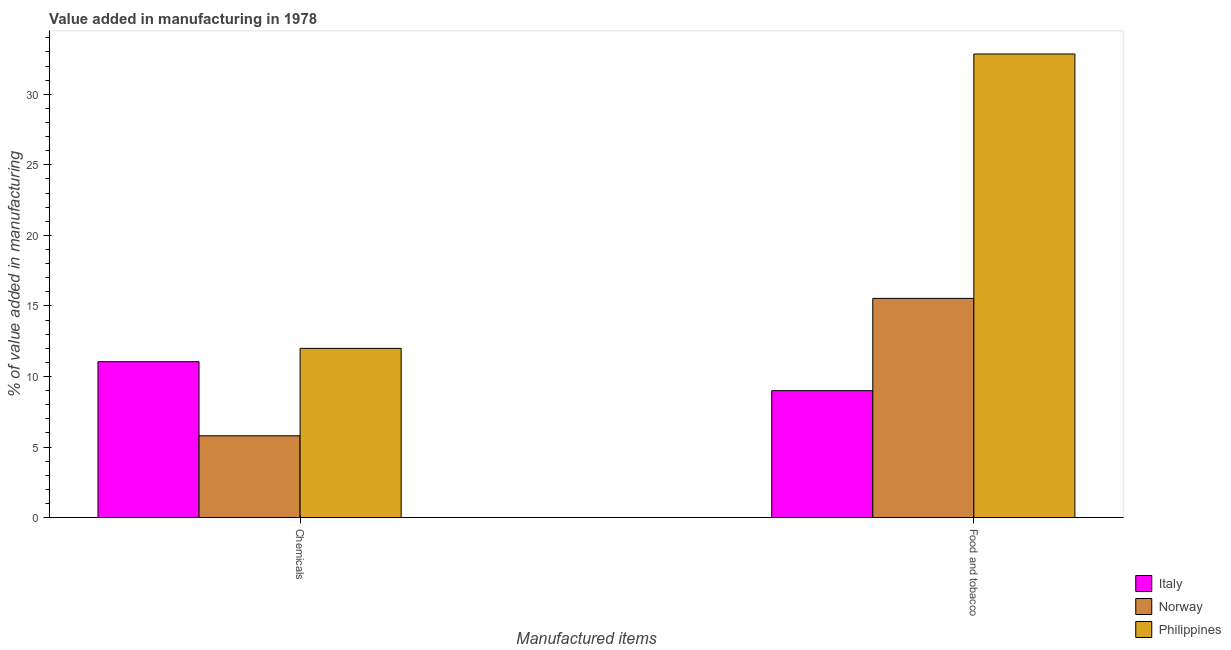How many groups of bars are there?
Offer a terse response. 2. How many bars are there on the 2nd tick from the left?
Your answer should be compact. 3. What is the label of the 1st group of bars from the left?
Provide a succinct answer. Chemicals. What is the value added by  manufacturing chemicals in Italy?
Offer a very short reply. 11.05. Across all countries, what is the maximum value added by manufacturing food and tobacco?
Make the answer very short. 32.85. Across all countries, what is the minimum value added by  manufacturing chemicals?
Ensure brevity in your answer.  5.8. In which country was the value added by  manufacturing chemicals minimum?
Keep it short and to the point. Norway. What is the total value added by manufacturing food and tobacco in the graph?
Keep it short and to the point. 57.38. What is the difference between the value added by manufacturing food and tobacco in Italy and that in Norway?
Offer a terse response. -6.54. What is the difference between the value added by manufacturing food and tobacco in Norway and the value added by  manufacturing chemicals in Italy?
Keep it short and to the point. 4.49. What is the average value added by  manufacturing chemicals per country?
Make the answer very short. 9.61. What is the difference between the value added by  manufacturing chemicals and value added by manufacturing food and tobacco in Philippines?
Ensure brevity in your answer.  -20.86. In how many countries, is the value added by manufacturing food and tobacco greater than 29 %?
Offer a very short reply. 1. What is the ratio of the value added by  manufacturing chemicals in Norway to that in Italy?
Offer a very short reply. 0.52. Is the value added by  manufacturing chemicals in Italy less than that in Norway?
Provide a succinct answer. No. In how many countries, is the value added by manufacturing food and tobacco greater than the average value added by manufacturing food and tobacco taken over all countries?
Your response must be concise. 1. What does the 1st bar from the left in Chemicals represents?
Provide a short and direct response. Italy. Are all the bars in the graph horizontal?
Offer a very short reply. No. How many countries are there in the graph?
Ensure brevity in your answer.  3. Are the values on the major ticks of Y-axis written in scientific E-notation?
Provide a short and direct response. No. Does the graph contain any zero values?
Ensure brevity in your answer.  No. Where does the legend appear in the graph?
Offer a very short reply. Bottom right. What is the title of the graph?
Offer a terse response. Value added in manufacturing in 1978. Does "Ghana" appear as one of the legend labels in the graph?
Your response must be concise. No. What is the label or title of the X-axis?
Your answer should be very brief. Manufactured items. What is the label or title of the Y-axis?
Your answer should be very brief. % of value added in manufacturing. What is the % of value added in manufacturing of Italy in Chemicals?
Keep it short and to the point. 11.05. What is the % of value added in manufacturing in Norway in Chemicals?
Provide a succinct answer. 5.8. What is the % of value added in manufacturing of Philippines in Chemicals?
Make the answer very short. 11.99. What is the % of value added in manufacturing in Italy in Food and tobacco?
Ensure brevity in your answer.  8.99. What is the % of value added in manufacturing in Norway in Food and tobacco?
Give a very brief answer. 15.53. What is the % of value added in manufacturing of Philippines in Food and tobacco?
Your answer should be compact. 32.85. Across all Manufactured items, what is the maximum % of value added in manufacturing of Italy?
Provide a short and direct response. 11.05. Across all Manufactured items, what is the maximum % of value added in manufacturing of Norway?
Offer a very short reply. 15.53. Across all Manufactured items, what is the maximum % of value added in manufacturing of Philippines?
Your answer should be compact. 32.85. Across all Manufactured items, what is the minimum % of value added in manufacturing of Italy?
Your answer should be compact. 8.99. Across all Manufactured items, what is the minimum % of value added in manufacturing in Norway?
Your answer should be compact. 5.8. Across all Manufactured items, what is the minimum % of value added in manufacturing in Philippines?
Your response must be concise. 11.99. What is the total % of value added in manufacturing of Italy in the graph?
Make the answer very short. 20.04. What is the total % of value added in manufacturing of Norway in the graph?
Provide a succinct answer. 21.33. What is the total % of value added in manufacturing of Philippines in the graph?
Give a very brief answer. 44.85. What is the difference between the % of value added in manufacturing of Italy in Chemicals and that in Food and tobacco?
Provide a short and direct response. 2.05. What is the difference between the % of value added in manufacturing in Norway in Chemicals and that in Food and tobacco?
Your response must be concise. -9.74. What is the difference between the % of value added in manufacturing of Philippines in Chemicals and that in Food and tobacco?
Provide a succinct answer. -20.86. What is the difference between the % of value added in manufacturing in Italy in Chemicals and the % of value added in manufacturing in Norway in Food and tobacco?
Offer a terse response. -4.49. What is the difference between the % of value added in manufacturing of Italy in Chemicals and the % of value added in manufacturing of Philippines in Food and tobacco?
Your answer should be compact. -21.81. What is the difference between the % of value added in manufacturing in Norway in Chemicals and the % of value added in manufacturing in Philippines in Food and tobacco?
Provide a succinct answer. -27.06. What is the average % of value added in manufacturing of Italy per Manufactured items?
Give a very brief answer. 10.02. What is the average % of value added in manufacturing of Norway per Manufactured items?
Your response must be concise. 10.66. What is the average % of value added in manufacturing in Philippines per Manufactured items?
Provide a short and direct response. 22.42. What is the difference between the % of value added in manufacturing of Italy and % of value added in manufacturing of Norway in Chemicals?
Offer a very short reply. 5.25. What is the difference between the % of value added in manufacturing in Italy and % of value added in manufacturing in Philippines in Chemicals?
Provide a succinct answer. -0.94. What is the difference between the % of value added in manufacturing in Norway and % of value added in manufacturing in Philippines in Chemicals?
Ensure brevity in your answer.  -6.2. What is the difference between the % of value added in manufacturing in Italy and % of value added in manufacturing in Norway in Food and tobacco?
Keep it short and to the point. -6.54. What is the difference between the % of value added in manufacturing of Italy and % of value added in manufacturing of Philippines in Food and tobacco?
Your answer should be compact. -23.86. What is the difference between the % of value added in manufacturing of Norway and % of value added in manufacturing of Philippines in Food and tobacco?
Ensure brevity in your answer.  -17.32. What is the ratio of the % of value added in manufacturing in Italy in Chemicals to that in Food and tobacco?
Your answer should be very brief. 1.23. What is the ratio of the % of value added in manufacturing of Norway in Chemicals to that in Food and tobacco?
Your answer should be compact. 0.37. What is the ratio of the % of value added in manufacturing of Philippines in Chemicals to that in Food and tobacco?
Provide a short and direct response. 0.36. What is the difference between the highest and the second highest % of value added in manufacturing of Italy?
Provide a succinct answer. 2.05. What is the difference between the highest and the second highest % of value added in manufacturing of Norway?
Your answer should be compact. 9.74. What is the difference between the highest and the second highest % of value added in manufacturing in Philippines?
Ensure brevity in your answer.  20.86. What is the difference between the highest and the lowest % of value added in manufacturing of Italy?
Your answer should be very brief. 2.05. What is the difference between the highest and the lowest % of value added in manufacturing in Norway?
Offer a terse response. 9.74. What is the difference between the highest and the lowest % of value added in manufacturing in Philippines?
Provide a succinct answer. 20.86. 